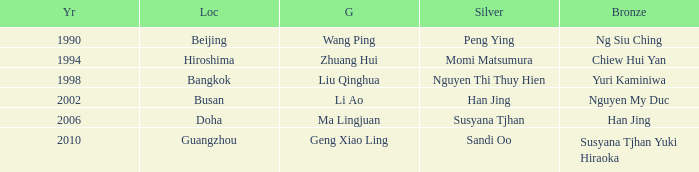What Gold has the Year of 1994? Zhuang Hui. 